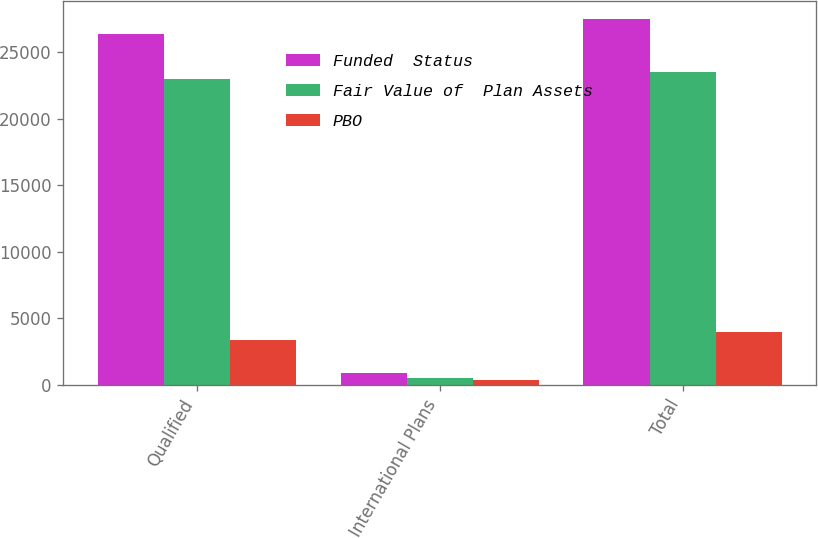<chart> <loc_0><loc_0><loc_500><loc_500><stacked_bar_chart><ecel><fcel>Qualified<fcel>International Plans<fcel>Total<nl><fcel>Funded  Status<fcel>26365<fcel>876<fcel>27512<nl><fcel>Fair Value of  Plan Assets<fcel>23006<fcel>499<fcel>23505<nl><fcel>PBO<fcel>3359<fcel>377<fcel>4007<nl></chart> 